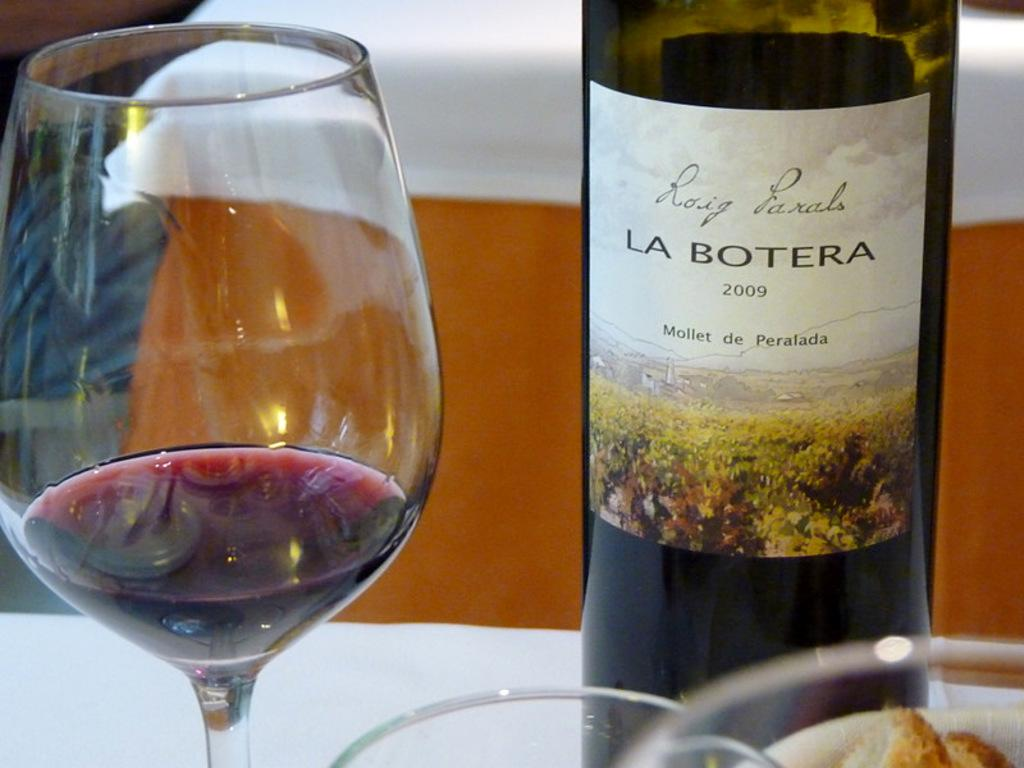What is inside the glass that is visible in the image? There is a glass filled with liquid content in the image. What else can be seen on the right side of the image? There is a bottle on the right side of the image. What information is provided on the bottle? The bottle is labelled as '2009 LA BOTERA'. Where is the gate located in the image? There is no gate present in the image. What type of market is visible in the image? There is no market present in the image. 